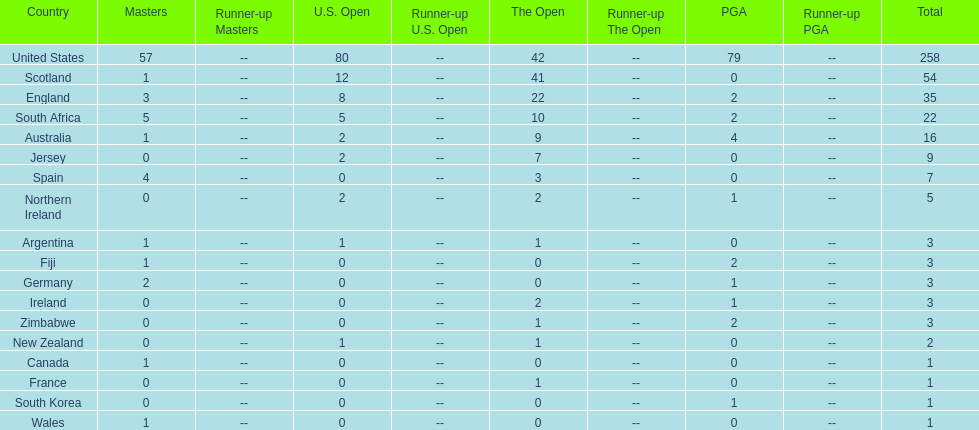Which african country has the least champion golfers according to this table? Zimbabwe. 